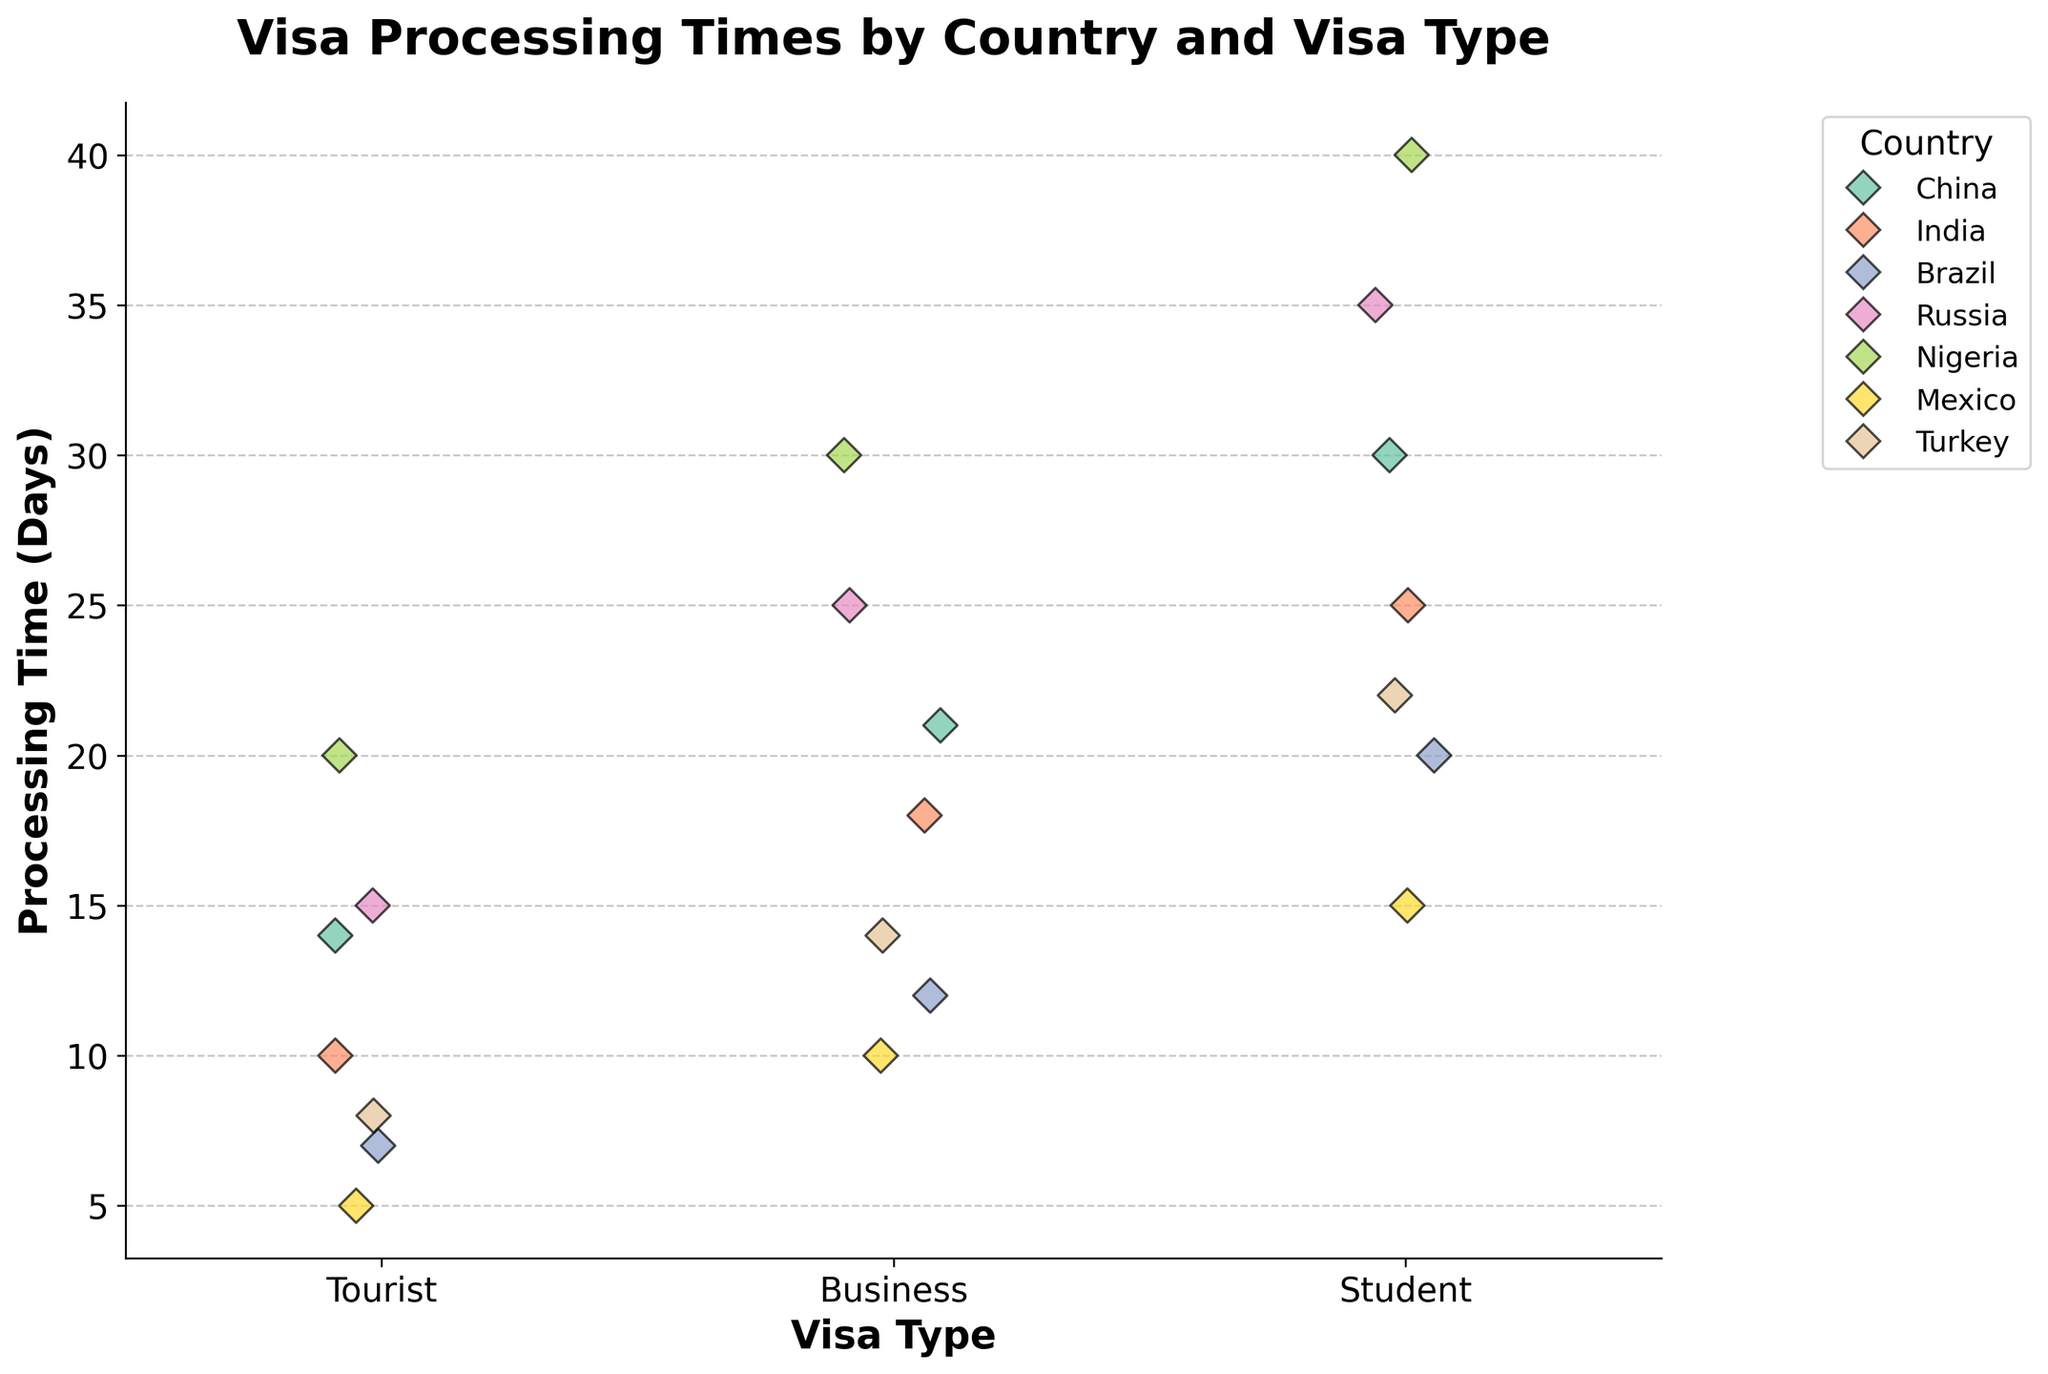What is the title of the plot? The title is located at the top of the plot, and it succinctly describes what the plot represents.
Answer: Visa Processing Times by Country and Visa Type What is the longest processing time for a Tourist visa, and which country does it belong to? By inspecting the plot under the 'Tourist' visa category, you can see that the longest processing time data point reaches up to 20 days and belongs to Nigeria (as indicated by the color associated with Nigeria in the legend).
Answer: 20 days, Nigeria Which country has the shortest average processing time across all visa types? First, determine the processing times for all visa types for each country, then calculate the average for each country. Compare these averages to find the shortest. For Brazil, the average is (7+12+20)/3 = 13 days; for China, the average is (14+21+30)/3 ≈ 21.67 days; for India, the average is (10+18+25)/3 ≈ 17.67 days; for Nigeria, the average is (20+30+40)/3 = 30 days; for Mexico, the average is (5+10+15)/3 = 10 days; and for Turkey, the average is (8+14+22)/3 ≈ 14.67 days. The country with the shortest average time is Mexico.
Answer: Mexico What is the difference in processing times for Student visas between Russia and Mexico? Locate the 'Student' visa category in the plot. Russia's processing time is at 35 days, while Mexico's processing time is at 15 days. The difference is 35 - 15 = 20 days.
Answer: 20 days Which country shows the most variation in visa processing times across different visa types? Measure the range (difference between the maximum and minimum values) of processing times within each country. China: 30-14=16 days; India: 25-10=15 days; Brazil: 20-7=13 days; Russia: 35-15=20 days; Nigeria: 40-20=20 days; Mexico: 15-5=10 days; Turkey: 22-8=14 days. The countries with the highest variation are Russia and Nigeria, both with a range of 20 days.
Answer: Russia and Nigeria 